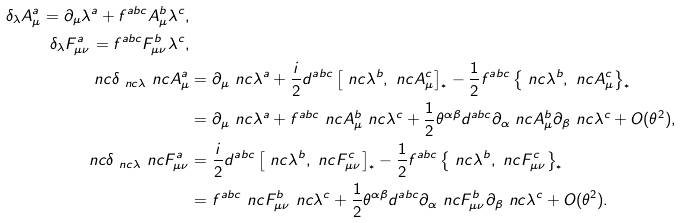Convert formula to latex. <formula><loc_0><loc_0><loc_500><loc_500>\delta _ { \lambda } A _ { \mu } ^ { a } = \partial _ { \mu } \lambda ^ { a } + f ^ { a b c } A _ { \mu } ^ { b } \lambda ^ { c } , \\ \delta _ { \lambda } F _ { \mu \nu } ^ { a } = f ^ { a b c } F _ { \mu \nu } ^ { b } \lambda ^ { c } , \\ \ n c { \delta } _ { \ n c { \lambda } } \ n c { A } _ { \mu } ^ { a } & = \partial _ { \mu } \ n c { \lambda } ^ { a } + \frac { i } { 2 } d ^ { a b c } \left [ \ n c { \lambda } ^ { b } , \ n c { A } _ { \mu } ^ { c } \right ] _ { ^ { * } } - \frac { 1 } { 2 } f ^ { a b c } \left \{ \ n c { \lambda } ^ { b } , \ n c { A } _ { \mu } ^ { c } \right \} _ { ^ { * } } \\ & = \partial _ { \mu } \ n c { \lambda } ^ { a } + f ^ { a b c } \ n c { A } _ { \mu } ^ { b } \ n c { \lambda } ^ { c } + \frac { 1 } { 2 } \theta ^ { \alpha \beta } d ^ { a b c } \partial _ { \alpha } \ n c { A } _ { \mu } ^ { b } \partial _ { \beta } \ n c { \lambda } ^ { c } + O ( \theta ^ { 2 } ) , \\ \ n c { \delta } _ { \ n c { \lambda } } \ n c { F } _ { \mu \nu } ^ { a } & = \frac { i } { 2 } d ^ { a b c } \left [ \ n c { \lambda } ^ { b } , \ n c { F } _ { \mu \nu } ^ { c } \right ] _ { ^ { * } } - \frac { 1 } { 2 } f ^ { a b c } \left \{ \ n c { \lambda } ^ { b } , \ n c { F } _ { \mu \nu } ^ { c } \right \} _ { ^ { * } } \\ & = f ^ { a b c } \ n c { F } _ { \mu \nu } ^ { b } \ n c { \lambda } ^ { c } + \frac { 1 } { 2 } \theta ^ { \alpha \beta } d ^ { a b c } \partial _ { \alpha } \ n c { F } _ { \mu \nu } ^ { b } \partial _ { \beta } \ n c { \lambda } ^ { c } + O ( \theta ^ { 2 } ) .</formula> 